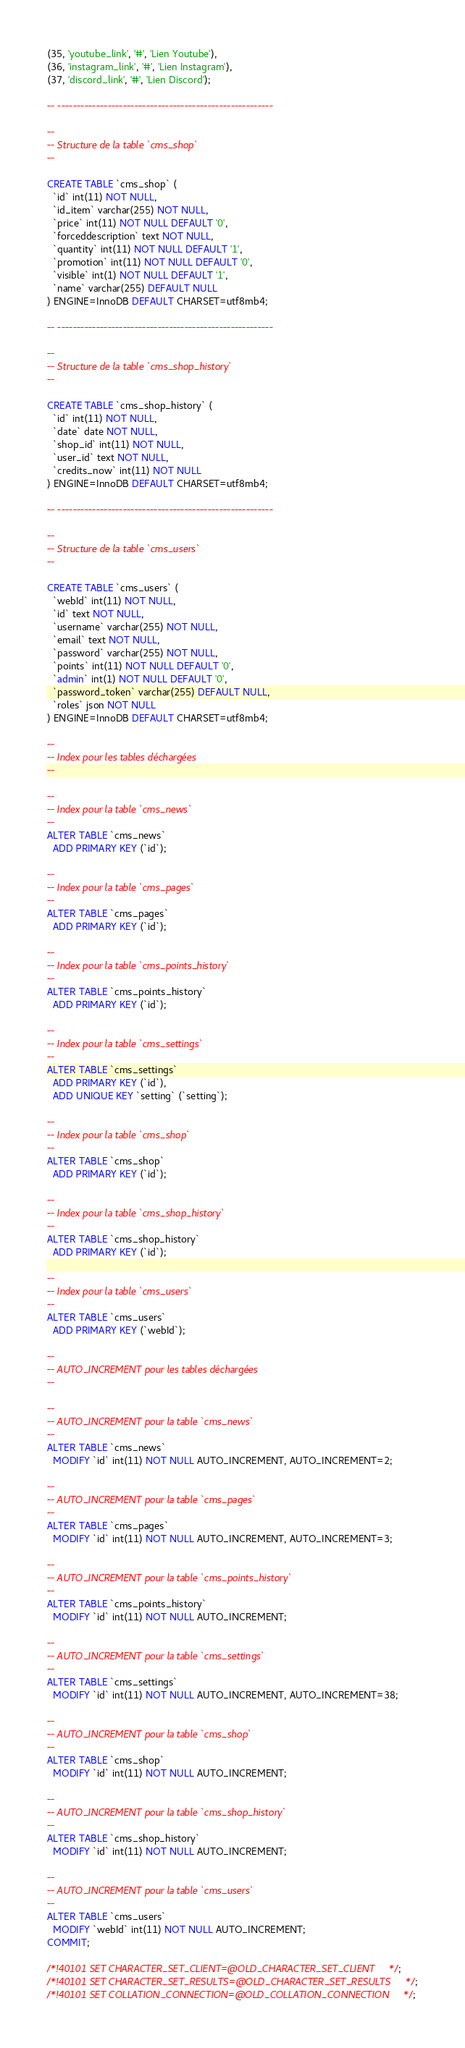<code> <loc_0><loc_0><loc_500><loc_500><_SQL_>(35, 'youtube_link', '#', 'Lien Youtube'),
(36, 'instagram_link', '#', 'Lien Instagram'),
(37, 'discord_link', '#', 'Lien Discord');

-- --------------------------------------------------------

--
-- Structure de la table `cms_shop`
--

CREATE TABLE `cms_shop` (
  `id` int(11) NOT NULL,
  `id_item` varchar(255) NOT NULL,
  `price` int(11) NOT NULL DEFAULT '0',
  `forceddescription` text NOT NULL,
  `quantity` int(11) NOT NULL DEFAULT '1',
  `promotion` int(11) NOT NULL DEFAULT '0',
  `visible` int(1) NOT NULL DEFAULT '1',
  `name` varchar(255) DEFAULT NULL
) ENGINE=InnoDB DEFAULT CHARSET=utf8mb4;

-- --------------------------------------------------------

--
-- Structure de la table `cms_shop_history`
--

CREATE TABLE `cms_shop_history` (
  `id` int(11) NOT NULL,
  `date` date NOT NULL,
  `shop_id` int(11) NOT NULL,
  `user_id` text NOT NULL,
  `credits_now` int(11) NOT NULL
) ENGINE=InnoDB DEFAULT CHARSET=utf8mb4;

-- --------------------------------------------------------

--
-- Structure de la table `cms_users`
--

CREATE TABLE `cms_users` (
  `webId` int(11) NOT NULL,
  `id` text NOT NULL,
  `username` varchar(255) NOT NULL,
  `email` text NOT NULL,
  `password` varchar(255) NOT NULL,
  `points` int(11) NOT NULL DEFAULT '0',
  `admin` int(1) NOT NULL DEFAULT '0',
  `password_token` varchar(255) DEFAULT NULL,
  `roles` json NOT NULL
) ENGINE=InnoDB DEFAULT CHARSET=utf8mb4;

--
-- Index pour les tables déchargées
--

--
-- Index pour la table `cms_news`
--
ALTER TABLE `cms_news`
  ADD PRIMARY KEY (`id`);

--
-- Index pour la table `cms_pages`
--
ALTER TABLE `cms_pages`
  ADD PRIMARY KEY (`id`);

--
-- Index pour la table `cms_points_history`
--
ALTER TABLE `cms_points_history`
  ADD PRIMARY KEY (`id`);

--
-- Index pour la table `cms_settings`
--
ALTER TABLE `cms_settings`
  ADD PRIMARY KEY (`id`),
  ADD UNIQUE KEY `setting` (`setting`);

--
-- Index pour la table `cms_shop`
--
ALTER TABLE `cms_shop`
  ADD PRIMARY KEY (`id`);

--
-- Index pour la table `cms_shop_history`
--
ALTER TABLE `cms_shop_history`
  ADD PRIMARY KEY (`id`);

--
-- Index pour la table `cms_users`
--
ALTER TABLE `cms_users`
  ADD PRIMARY KEY (`webId`);

--
-- AUTO_INCREMENT pour les tables déchargées
--

--
-- AUTO_INCREMENT pour la table `cms_news`
--
ALTER TABLE `cms_news`
  MODIFY `id` int(11) NOT NULL AUTO_INCREMENT, AUTO_INCREMENT=2;

--
-- AUTO_INCREMENT pour la table `cms_pages`
--
ALTER TABLE `cms_pages`
  MODIFY `id` int(11) NOT NULL AUTO_INCREMENT, AUTO_INCREMENT=3;

--
-- AUTO_INCREMENT pour la table `cms_points_history`
--
ALTER TABLE `cms_points_history`
  MODIFY `id` int(11) NOT NULL AUTO_INCREMENT;

--
-- AUTO_INCREMENT pour la table `cms_settings`
--
ALTER TABLE `cms_settings`
  MODIFY `id` int(11) NOT NULL AUTO_INCREMENT, AUTO_INCREMENT=38;

--
-- AUTO_INCREMENT pour la table `cms_shop`
--
ALTER TABLE `cms_shop`
  MODIFY `id` int(11) NOT NULL AUTO_INCREMENT;

--
-- AUTO_INCREMENT pour la table `cms_shop_history`
--
ALTER TABLE `cms_shop_history`
  MODIFY `id` int(11) NOT NULL AUTO_INCREMENT;

--
-- AUTO_INCREMENT pour la table `cms_users`
--
ALTER TABLE `cms_users`
  MODIFY `webId` int(11) NOT NULL AUTO_INCREMENT;
COMMIT;

/*!40101 SET CHARACTER_SET_CLIENT=@OLD_CHARACTER_SET_CLIENT */;
/*!40101 SET CHARACTER_SET_RESULTS=@OLD_CHARACTER_SET_RESULTS */;
/*!40101 SET COLLATION_CONNECTION=@OLD_COLLATION_CONNECTION */;
</code> 